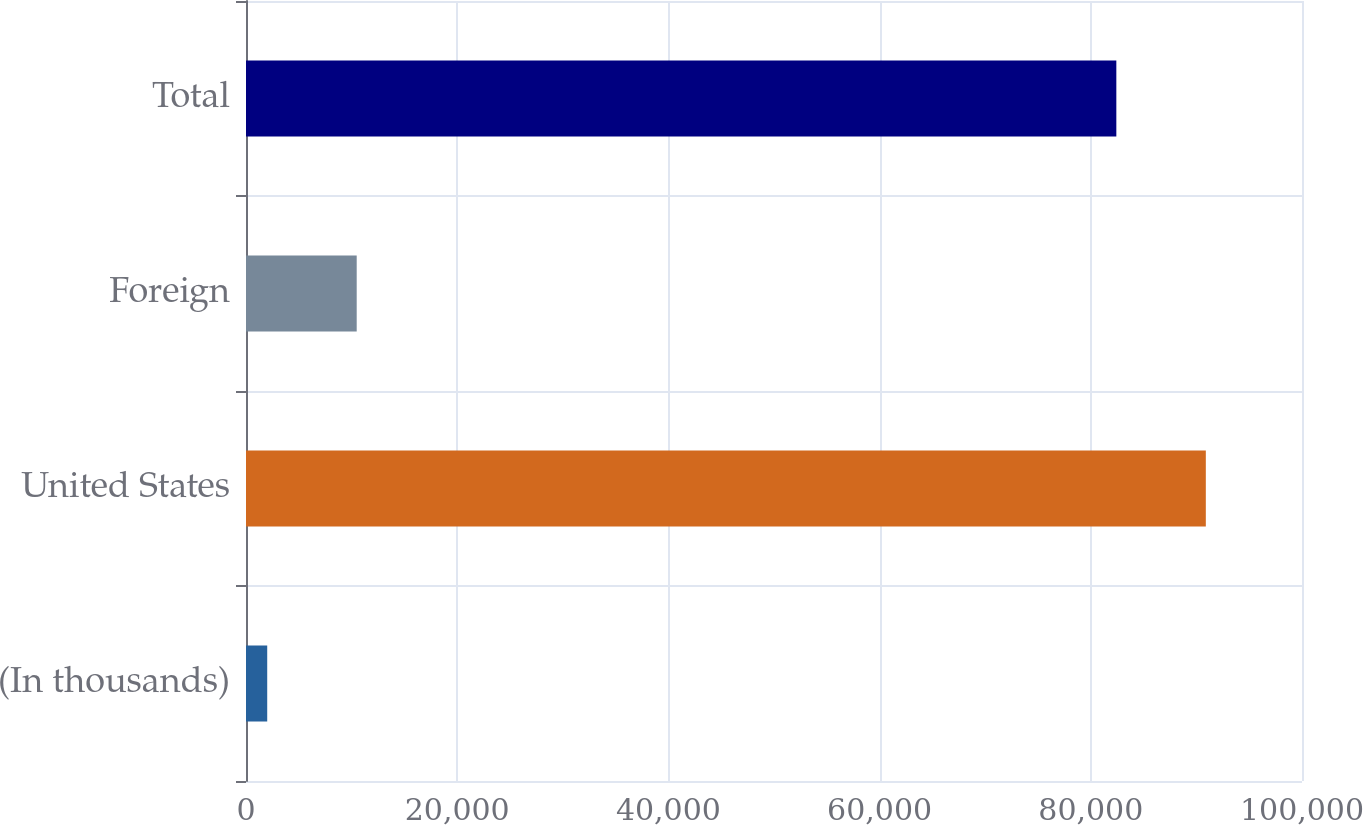Convert chart. <chart><loc_0><loc_0><loc_500><loc_500><bar_chart><fcel>(In thousands)<fcel>United States<fcel>Foreign<fcel>Total<nl><fcel>2009<fcel>90892.3<fcel>10483.3<fcel>82418<nl></chart> 